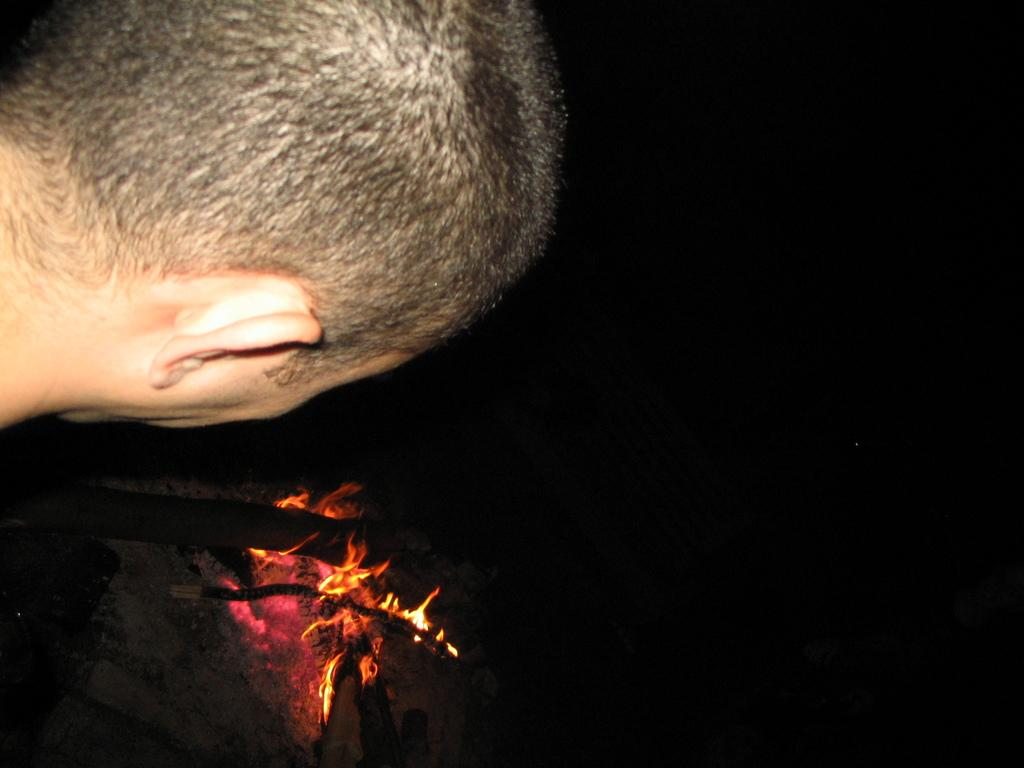Who or what is located in the front of the image? There is a person in the front of the image. What can be seen in the center of the image? There is a bonfire in the center of the image. How many dogs are present in the image? There are no dogs present in the image. What direction is the bonfire facing in the image? The bonfire is not facing a specific direction, as it is a fire in the center of the image. 